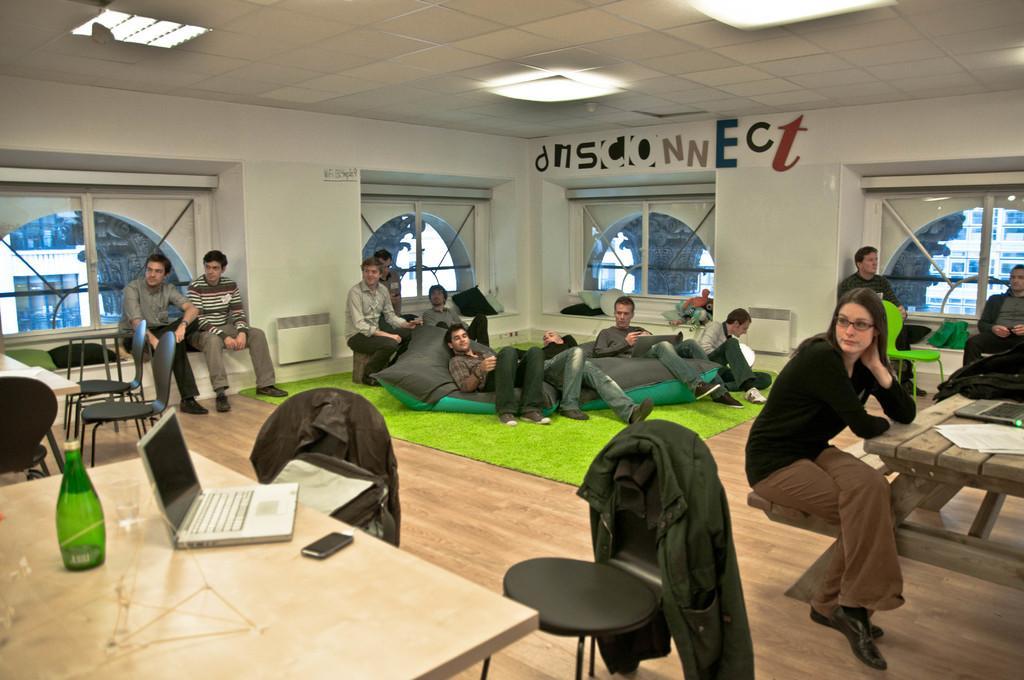In one or two sentences, can you explain what this image depicts? There are few people here sitting. On the table we can see a bottle,laptop,mobile phone. There are few chairs also here. Through window we can see building. 